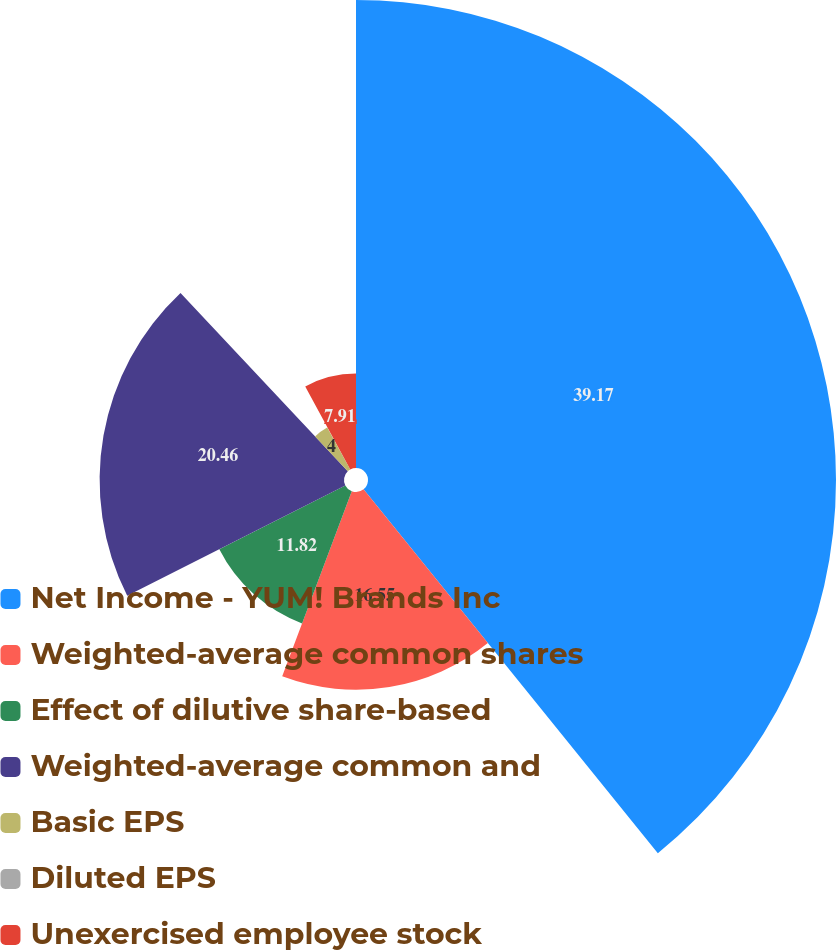Convert chart. <chart><loc_0><loc_0><loc_500><loc_500><pie_chart><fcel>Net Income - YUM! Brands Inc<fcel>Weighted-average common shares<fcel>Effect of dilutive share-based<fcel>Weighted-average common and<fcel>Basic EPS<fcel>Diluted EPS<fcel>Unexercised employee stock<nl><fcel>39.18%<fcel>16.55%<fcel>11.82%<fcel>20.46%<fcel>4.0%<fcel>0.09%<fcel>7.91%<nl></chart> 